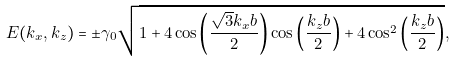Convert formula to latex. <formula><loc_0><loc_0><loc_500><loc_500>E ( k _ { x } , k _ { z } ) = \pm \gamma _ { 0 } \sqrt { 1 + 4 \cos \left ( \frac { \sqrt { 3 } k _ { x } b } { 2 } \right ) \cos \left ( \frac { k _ { z } b } { 2 } \right ) + 4 \cos ^ { 2 } \left ( \frac { k _ { z } b } { 2 } \right ) } ,</formula> 